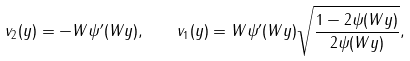<formula> <loc_0><loc_0><loc_500><loc_500>v _ { 2 } ( y ) = - W \psi ^ { \prime } ( W y ) , \quad v _ { 1 } ( y ) = W \psi ^ { \prime } ( W y ) \sqrt { \frac { 1 - 2 \psi ( W y ) } { 2 \psi ( W y ) } } ,</formula> 